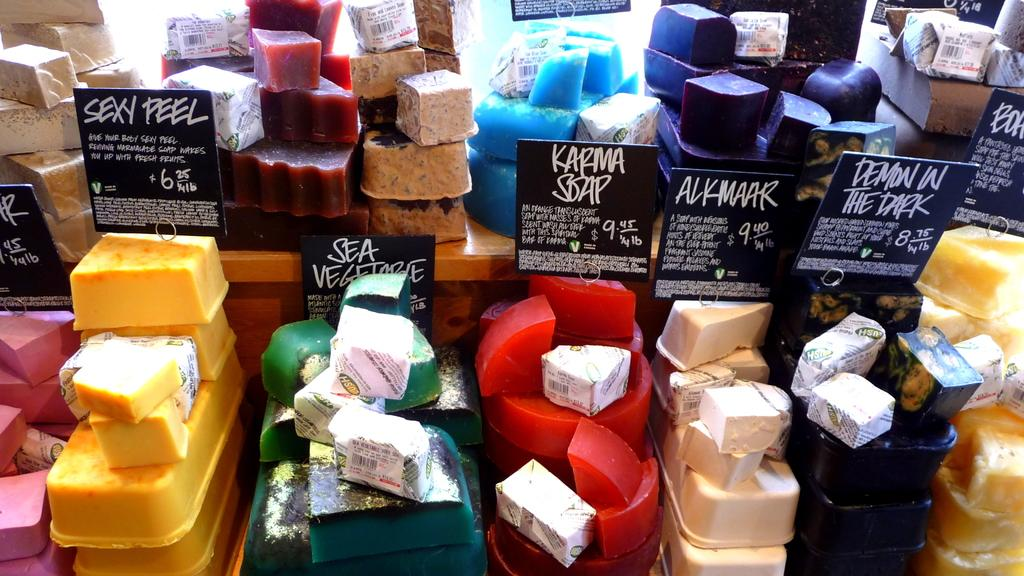What can be seen in the image? There are objects in the image. What type of objects are present in the image? There are blackboards in the image. What is written on the blackboards? There is text written on the blackboards. Where can a cushion be found in the image? There is no cushion present in the image. What type of park is visible in the image? There is no park present in the image. 